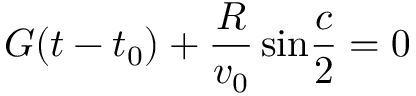Convert formula to latex. <formula><loc_0><loc_0><loc_500><loc_500>G ( t - t _ { 0 } ) + { \frac { R } { v _ { 0 } } } \, \sin { \frac { c } { 2 } } = 0</formula> 